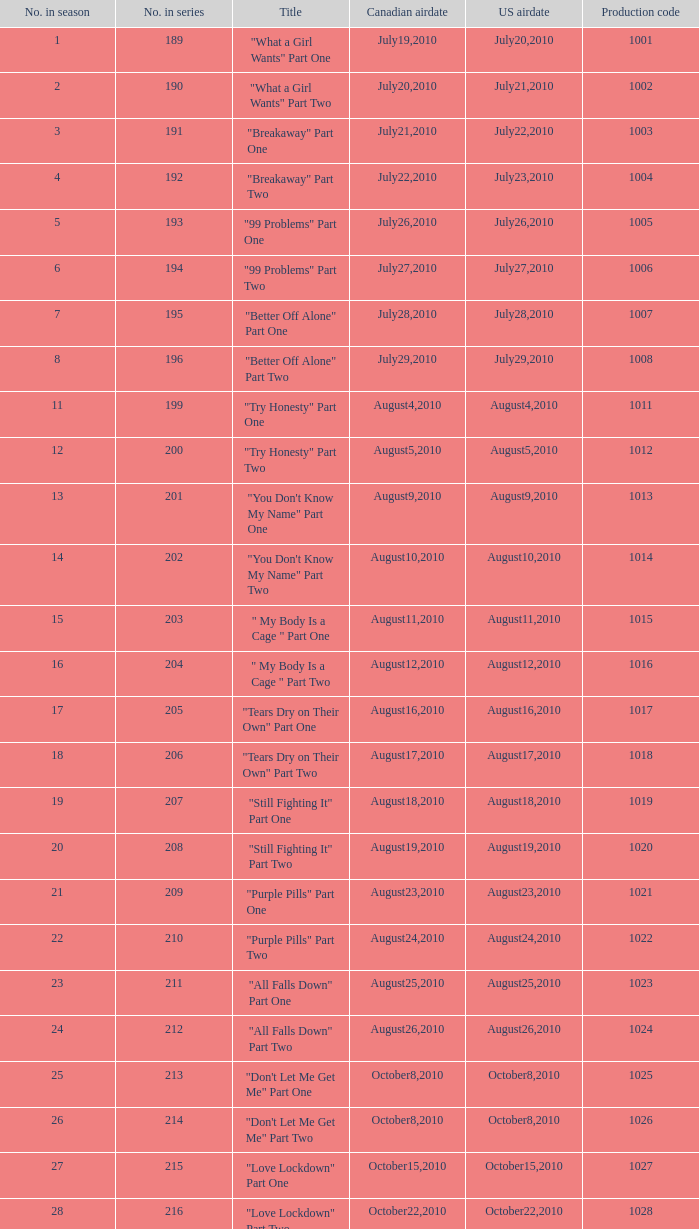How many titles possessed production code 1040? 1.0. 